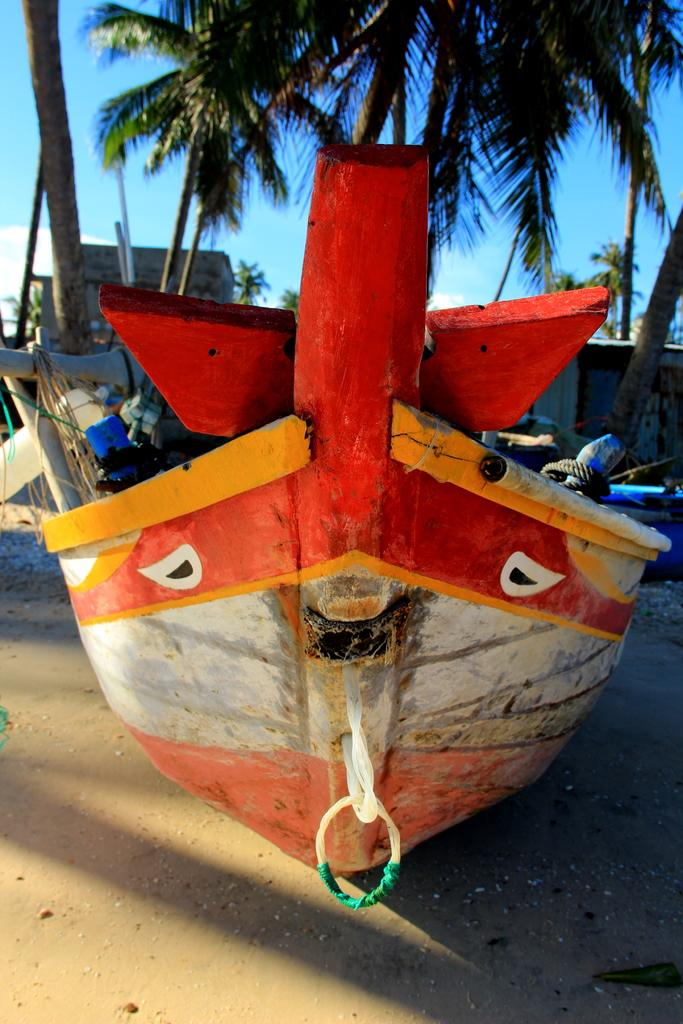What is the main subject of the image? The main subject of the image is a boat. Where is the boat located in the image? The boat is on the sand in the image. What can be seen in the background of the image? There are trees, a house, and the sky visible in the background of the image. What type of jam is being spread on the boat in the image? There is no jam present in the image, and the boat is not being used for spreading jam. 